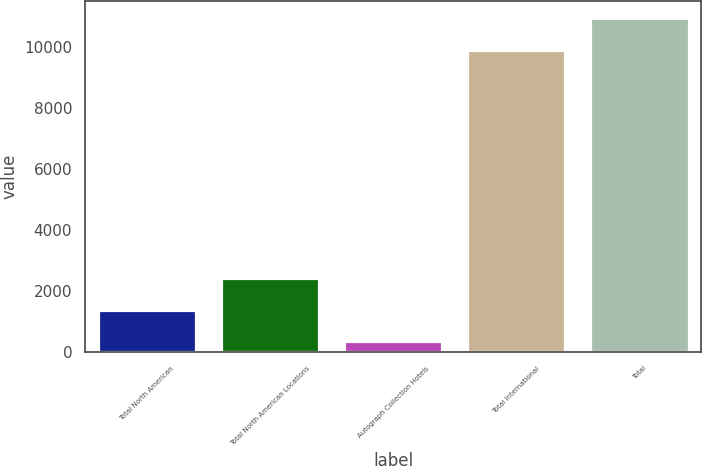Convert chart. <chart><loc_0><loc_0><loc_500><loc_500><bar_chart><fcel>Total North American<fcel>Total North American Locations<fcel>Autograph Collection Hotels<fcel>Total International<fcel>Total<nl><fcel>1394.2<fcel>2440.4<fcel>348<fcel>9899<fcel>10945.2<nl></chart> 